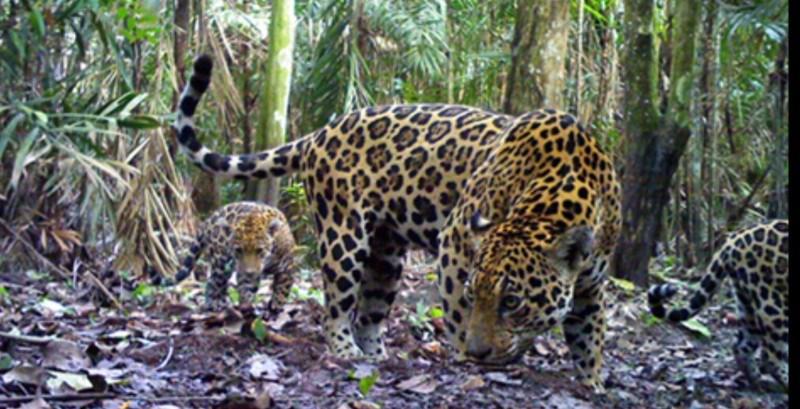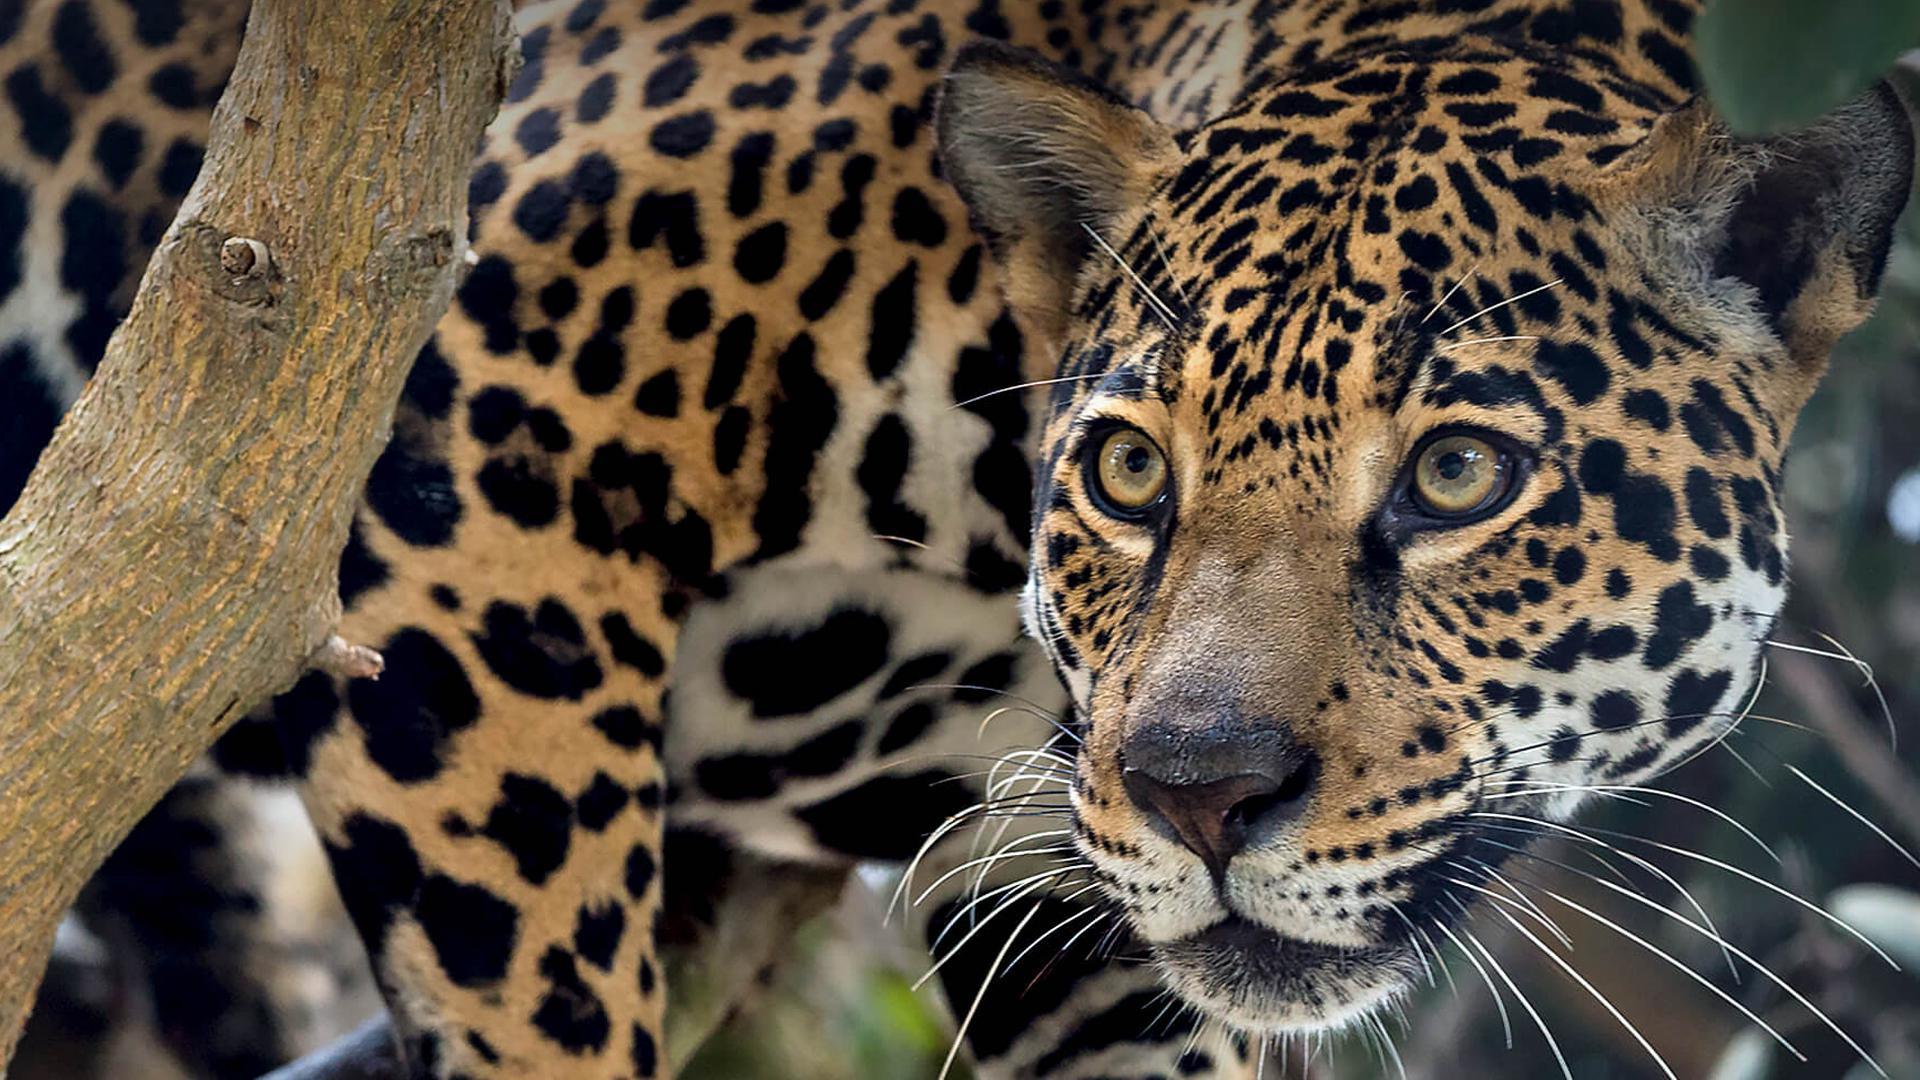The first image is the image on the left, the second image is the image on the right. Evaluate the accuracy of this statement regarding the images: "At least one image shows a group of at least three spotted cats, clustered together.". Is it true? Answer yes or no. No. The first image is the image on the left, the second image is the image on the right. For the images shown, is this caption "there are at least three animals in the image on the left." true? Answer yes or no. Yes. 